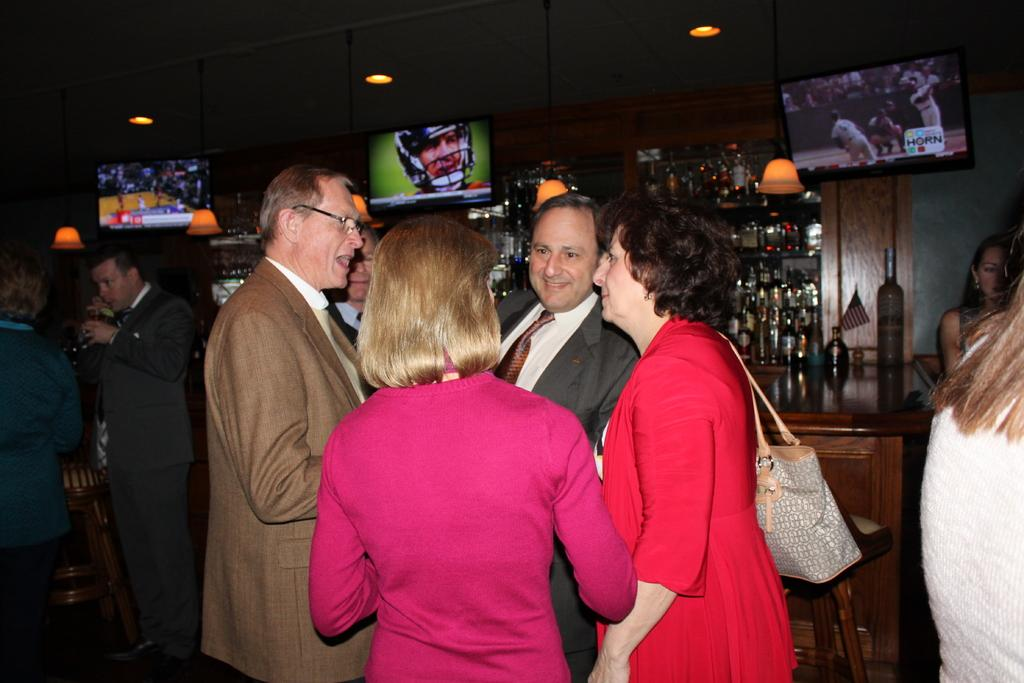What can be seen in the image? There are people standing in the image. Where are the people standing? The people are standing on the floor. What can be seen in the background of the image? There are beverage bottles in the shelves, display screens, and electric lights visible in the background. What type of science experiment is being conducted by the people in the image? There is no indication of a science experiment in the image; it simply shows people standing on the floor. 